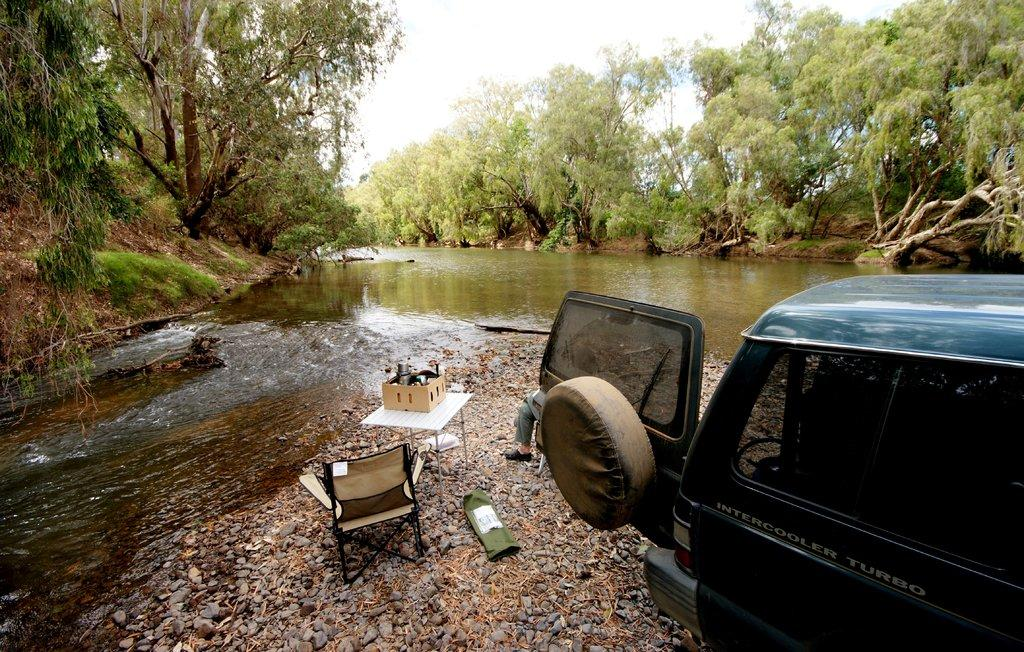What is present in the image that is not solid? Water is visible in the image, which is not solid. What type of natural environment is depicted in the image? The image contains trees and water, which suggests a natural setting. What is visible in the sky in the image? The sky is visible in the image, but no specific details about the sky are provided. What type of man-made objects can be seen in the image? There is a vehicle, a chair, and a table in the image. What is on the table in the image? There is an unspecified object on the table in the image. What type of flag is being waved by the apple in the image? There is no flag or apple present in the image. 